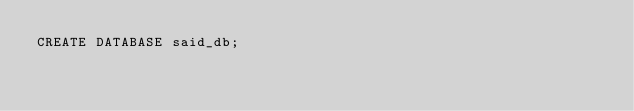<code> <loc_0><loc_0><loc_500><loc_500><_SQL_>CREATE DATABASE said_db;
</code> 